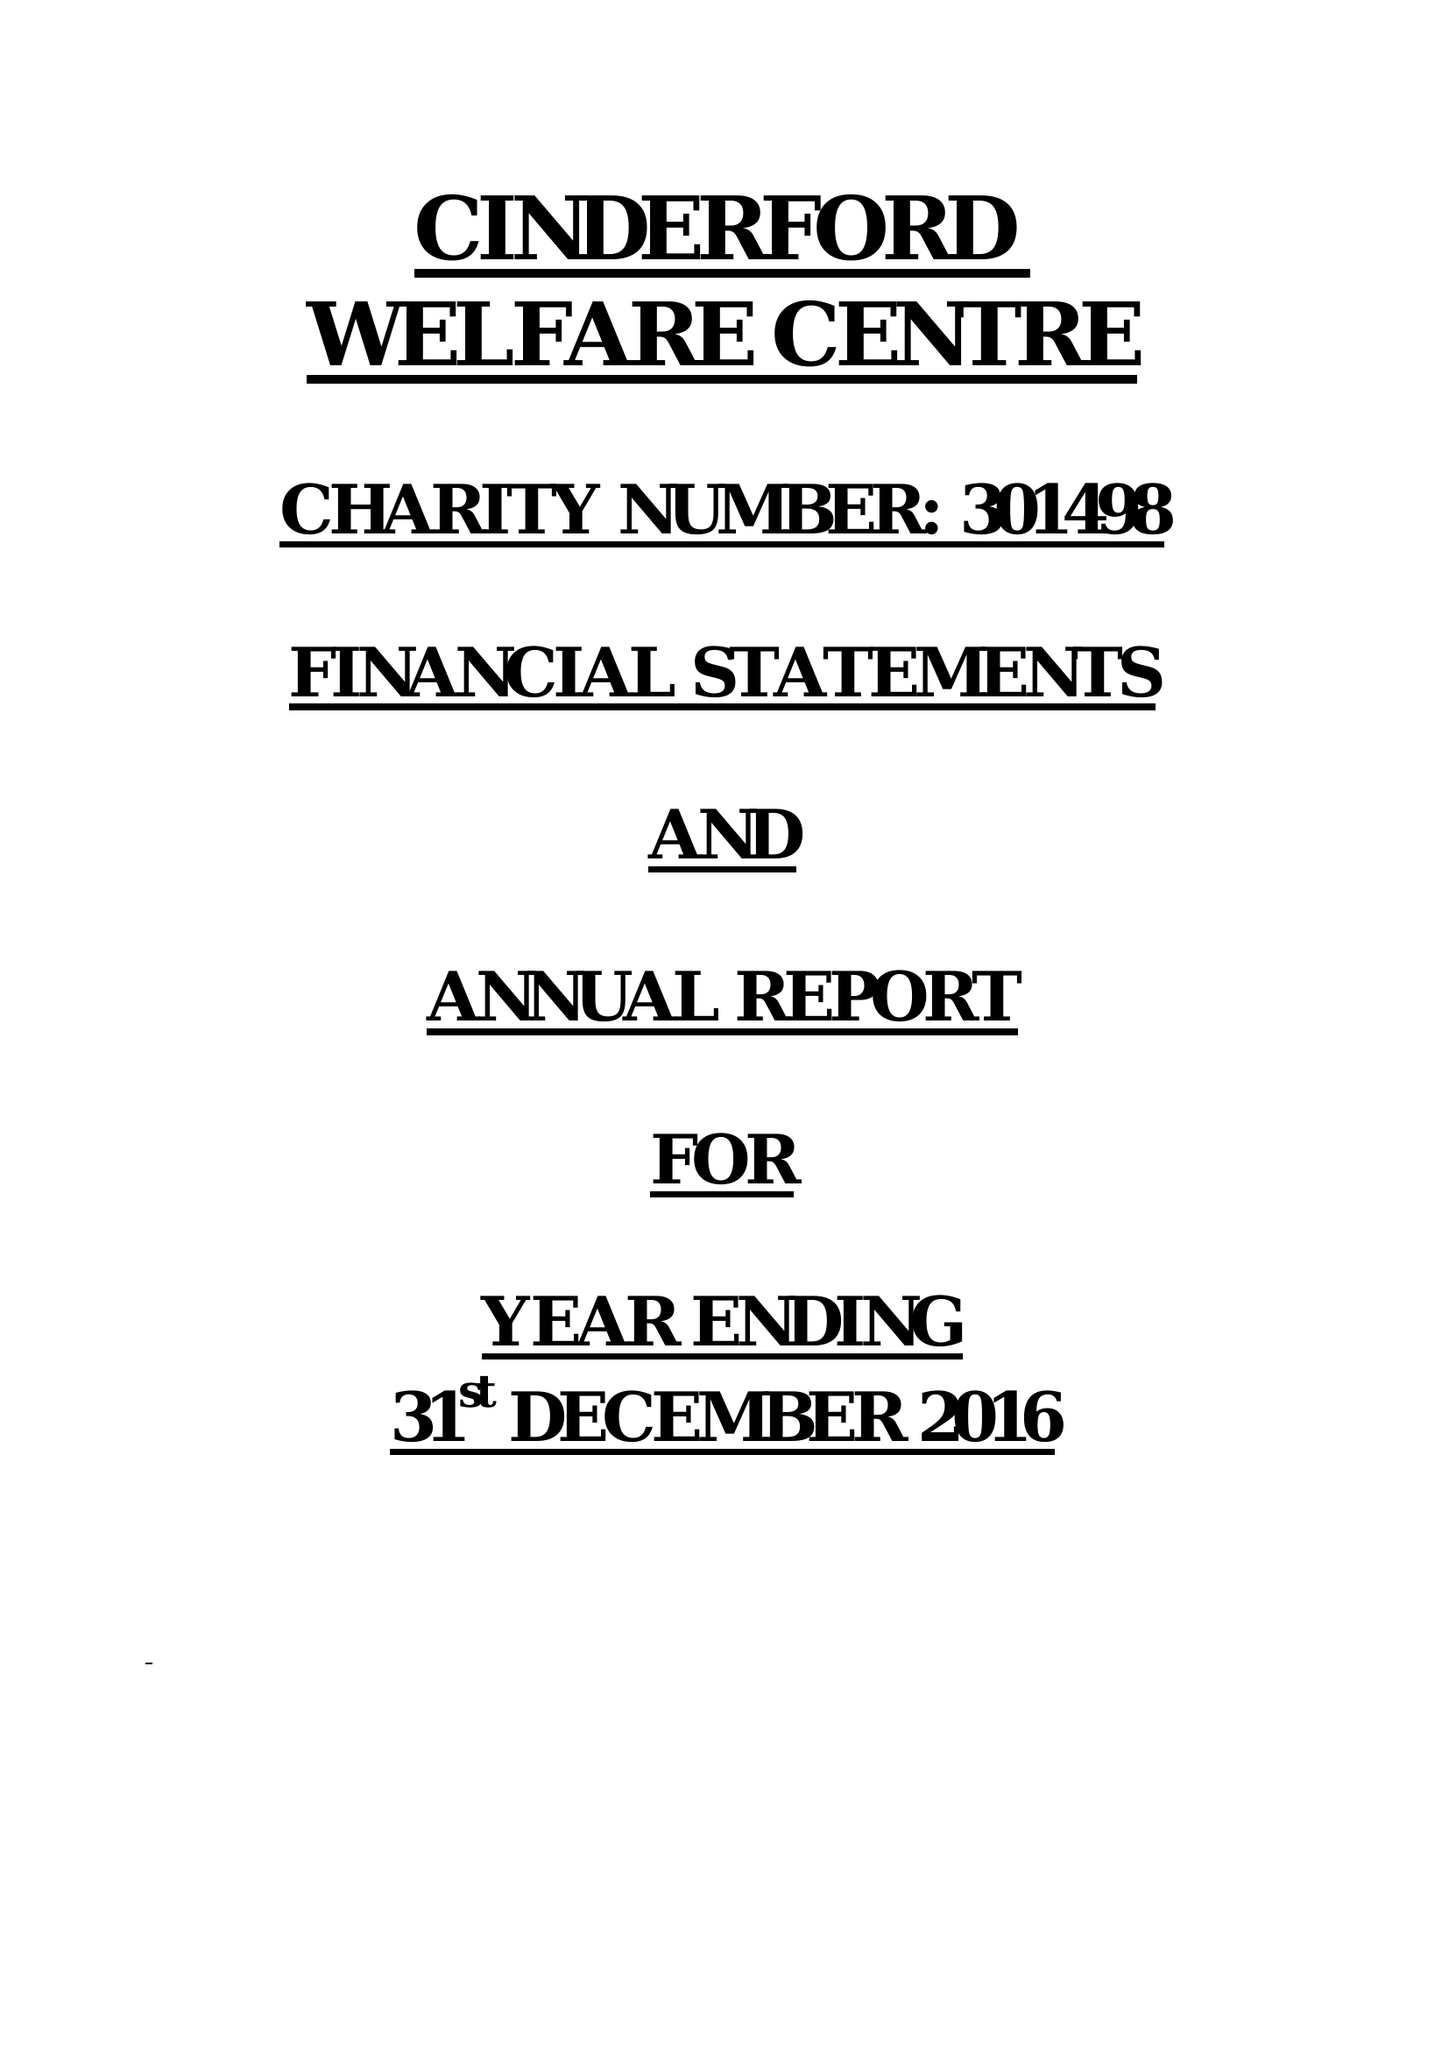What is the value for the spending_annually_in_british_pounds?
Answer the question using a single word or phrase. 40734.00 